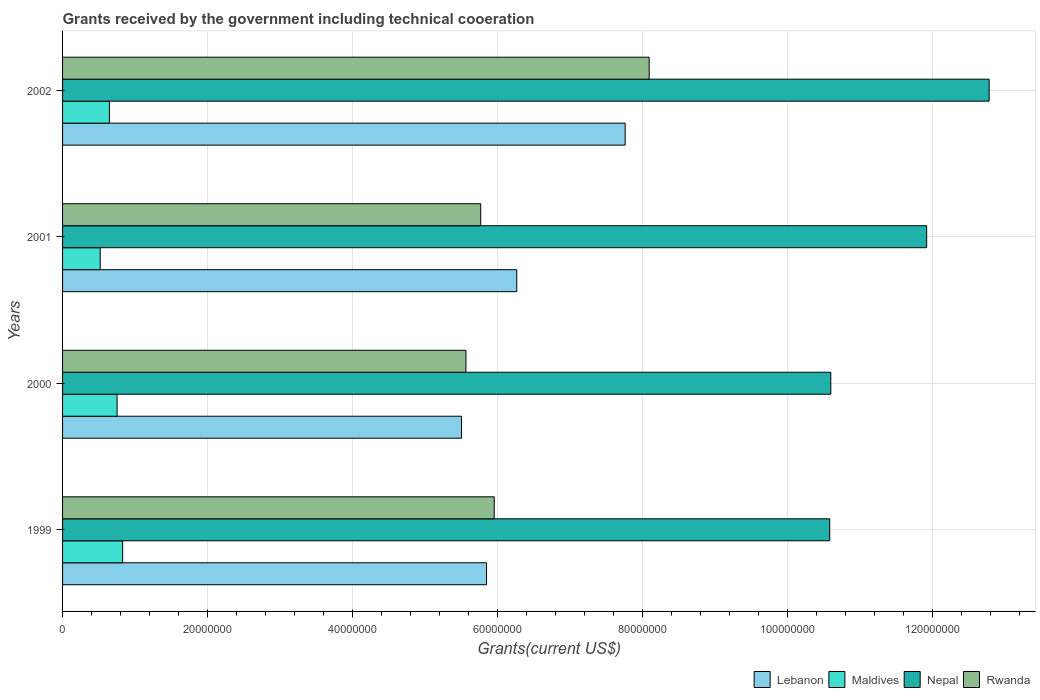How many groups of bars are there?
Keep it short and to the point. 4. In how many cases, is the number of bars for a given year not equal to the number of legend labels?
Give a very brief answer. 0. What is the total grants received by the government in Nepal in 2002?
Offer a very short reply. 1.28e+08. Across all years, what is the maximum total grants received by the government in Lebanon?
Ensure brevity in your answer.  7.76e+07. Across all years, what is the minimum total grants received by the government in Maldives?
Provide a short and direct response. 5.19e+06. What is the total total grants received by the government in Rwanda in the graph?
Offer a terse response. 2.54e+08. What is the difference between the total grants received by the government in Maldives in 1999 and that in 2001?
Your response must be concise. 3.10e+06. What is the difference between the total grants received by the government in Nepal in 2000 and the total grants received by the government in Maldives in 2002?
Ensure brevity in your answer.  9.95e+07. What is the average total grants received by the government in Lebanon per year?
Provide a short and direct response. 6.34e+07. In the year 1999, what is the difference between the total grants received by the government in Nepal and total grants received by the government in Rwanda?
Provide a succinct answer. 4.63e+07. In how many years, is the total grants received by the government in Lebanon greater than 68000000 US$?
Your response must be concise. 1. What is the ratio of the total grants received by the government in Maldives in 1999 to that in 2001?
Keep it short and to the point. 1.6. What is the difference between the highest and the second highest total grants received by the government in Rwanda?
Provide a succinct answer. 2.14e+07. What is the difference between the highest and the lowest total grants received by the government in Lebanon?
Your response must be concise. 2.26e+07. Is the sum of the total grants received by the government in Maldives in 2001 and 2002 greater than the maximum total grants received by the government in Rwanda across all years?
Offer a terse response. No. What does the 2nd bar from the top in 2002 represents?
Keep it short and to the point. Nepal. What does the 1st bar from the bottom in 2000 represents?
Make the answer very short. Lebanon. What is the difference between two consecutive major ticks on the X-axis?
Offer a very short reply. 2.00e+07. Are the values on the major ticks of X-axis written in scientific E-notation?
Offer a terse response. No. Does the graph contain grids?
Ensure brevity in your answer.  Yes. How many legend labels are there?
Offer a terse response. 4. What is the title of the graph?
Keep it short and to the point. Grants received by the government including technical cooeration. What is the label or title of the X-axis?
Your response must be concise. Grants(current US$). What is the label or title of the Y-axis?
Your answer should be very brief. Years. What is the Grants(current US$) in Lebanon in 1999?
Your response must be concise. 5.85e+07. What is the Grants(current US$) of Maldives in 1999?
Your response must be concise. 8.29e+06. What is the Grants(current US$) in Nepal in 1999?
Give a very brief answer. 1.06e+08. What is the Grants(current US$) of Rwanda in 1999?
Give a very brief answer. 5.95e+07. What is the Grants(current US$) of Lebanon in 2000?
Provide a short and direct response. 5.50e+07. What is the Grants(current US$) of Maldives in 2000?
Keep it short and to the point. 7.52e+06. What is the Grants(current US$) of Nepal in 2000?
Offer a terse response. 1.06e+08. What is the Grants(current US$) in Rwanda in 2000?
Your answer should be compact. 5.56e+07. What is the Grants(current US$) of Lebanon in 2001?
Provide a succinct answer. 6.26e+07. What is the Grants(current US$) in Maldives in 2001?
Your answer should be very brief. 5.19e+06. What is the Grants(current US$) of Nepal in 2001?
Provide a succinct answer. 1.19e+08. What is the Grants(current US$) in Rwanda in 2001?
Your answer should be compact. 5.77e+07. What is the Grants(current US$) of Lebanon in 2002?
Provide a succinct answer. 7.76e+07. What is the Grants(current US$) in Maldives in 2002?
Give a very brief answer. 6.46e+06. What is the Grants(current US$) in Nepal in 2002?
Your answer should be very brief. 1.28e+08. What is the Grants(current US$) of Rwanda in 2002?
Give a very brief answer. 8.09e+07. Across all years, what is the maximum Grants(current US$) of Lebanon?
Your answer should be compact. 7.76e+07. Across all years, what is the maximum Grants(current US$) in Maldives?
Provide a succinct answer. 8.29e+06. Across all years, what is the maximum Grants(current US$) in Nepal?
Offer a terse response. 1.28e+08. Across all years, what is the maximum Grants(current US$) of Rwanda?
Give a very brief answer. 8.09e+07. Across all years, what is the minimum Grants(current US$) in Lebanon?
Make the answer very short. 5.50e+07. Across all years, what is the minimum Grants(current US$) in Maldives?
Your response must be concise. 5.19e+06. Across all years, what is the minimum Grants(current US$) in Nepal?
Your response must be concise. 1.06e+08. Across all years, what is the minimum Grants(current US$) of Rwanda?
Your response must be concise. 5.56e+07. What is the total Grants(current US$) in Lebanon in the graph?
Provide a succinct answer. 2.54e+08. What is the total Grants(current US$) in Maldives in the graph?
Your response must be concise. 2.75e+07. What is the total Grants(current US$) of Nepal in the graph?
Make the answer very short. 4.59e+08. What is the total Grants(current US$) in Rwanda in the graph?
Keep it short and to the point. 2.54e+08. What is the difference between the Grants(current US$) of Lebanon in 1999 and that in 2000?
Ensure brevity in your answer.  3.45e+06. What is the difference between the Grants(current US$) in Maldives in 1999 and that in 2000?
Provide a succinct answer. 7.70e+05. What is the difference between the Grants(current US$) of Rwanda in 1999 and that in 2000?
Keep it short and to the point. 3.90e+06. What is the difference between the Grants(current US$) of Lebanon in 1999 and that in 2001?
Make the answer very short. -4.17e+06. What is the difference between the Grants(current US$) of Maldives in 1999 and that in 2001?
Provide a short and direct response. 3.10e+06. What is the difference between the Grants(current US$) in Nepal in 1999 and that in 2001?
Give a very brief answer. -1.34e+07. What is the difference between the Grants(current US$) in Rwanda in 1999 and that in 2001?
Ensure brevity in your answer.  1.86e+06. What is the difference between the Grants(current US$) in Lebanon in 1999 and that in 2002?
Provide a short and direct response. -1.91e+07. What is the difference between the Grants(current US$) in Maldives in 1999 and that in 2002?
Offer a very short reply. 1.83e+06. What is the difference between the Grants(current US$) of Nepal in 1999 and that in 2002?
Offer a very short reply. -2.20e+07. What is the difference between the Grants(current US$) of Rwanda in 1999 and that in 2002?
Keep it short and to the point. -2.14e+07. What is the difference between the Grants(current US$) of Lebanon in 2000 and that in 2001?
Ensure brevity in your answer.  -7.62e+06. What is the difference between the Grants(current US$) in Maldives in 2000 and that in 2001?
Your answer should be compact. 2.33e+06. What is the difference between the Grants(current US$) in Nepal in 2000 and that in 2001?
Your answer should be very brief. -1.32e+07. What is the difference between the Grants(current US$) of Rwanda in 2000 and that in 2001?
Your answer should be very brief. -2.04e+06. What is the difference between the Grants(current US$) of Lebanon in 2000 and that in 2002?
Your answer should be very brief. -2.26e+07. What is the difference between the Grants(current US$) in Maldives in 2000 and that in 2002?
Ensure brevity in your answer.  1.06e+06. What is the difference between the Grants(current US$) of Nepal in 2000 and that in 2002?
Make the answer very short. -2.18e+07. What is the difference between the Grants(current US$) of Rwanda in 2000 and that in 2002?
Your answer should be very brief. -2.53e+07. What is the difference between the Grants(current US$) in Lebanon in 2001 and that in 2002?
Provide a succinct answer. -1.50e+07. What is the difference between the Grants(current US$) in Maldives in 2001 and that in 2002?
Make the answer very short. -1.27e+06. What is the difference between the Grants(current US$) of Nepal in 2001 and that in 2002?
Your answer should be very brief. -8.62e+06. What is the difference between the Grants(current US$) in Rwanda in 2001 and that in 2002?
Provide a short and direct response. -2.32e+07. What is the difference between the Grants(current US$) of Lebanon in 1999 and the Grants(current US$) of Maldives in 2000?
Ensure brevity in your answer.  5.10e+07. What is the difference between the Grants(current US$) of Lebanon in 1999 and the Grants(current US$) of Nepal in 2000?
Give a very brief answer. -4.75e+07. What is the difference between the Grants(current US$) of Lebanon in 1999 and the Grants(current US$) of Rwanda in 2000?
Provide a succinct answer. 2.84e+06. What is the difference between the Grants(current US$) in Maldives in 1999 and the Grants(current US$) in Nepal in 2000?
Provide a short and direct response. -9.77e+07. What is the difference between the Grants(current US$) of Maldives in 1999 and the Grants(current US$) of Rwanda in 2000?
Your answer should be very brief. -4.73e+07. What is the difference between the Grants(current US$) in Nepal in 1999 and the Grants(current US$) in Rwanda in 2000?
Keep it short and to the point. 5.02e+07. What is the difference between the Grants(current US$) of Lebanon in 1999 and the Grants(current US$) of Maldives in 2001?
Your answer should be compact. 5.33e+07. What is the difference between the Grants(current US$) of Lebanon in 1999 and the Grants(current US$) of Nepal in 2001?
Provide a succinct answer. -6.07e+07. What is the difference between the Grants(current US$) in Maldives in 1999 and the Grants(current US$) in Nepal in 2001?
Provide a succinct answer. -1.11e+08. What is the difference between the Grants(current US$) in Maldives in 1999 and the Grants(current US$) in Rwanda in 2001?
Make the answer very short. -4.94e+07. What is the difference between the Grants(current US$) in Nepal in 1999 and the Grants(current US$) in Rwanda in 2001?
Your answer should be very brief. 4.81e+07. What is the difference between the Grants(current US$) of Lebanon in 1999 and the Grants(current US$) of Maldives in 2002?
Keep it short and to the point. 5.20e+07. What is the difference between the Grants(current US$) of Lebanon in 1999 and the Grants(current US$) of Nepal in 2002?
Your answer should be compact. -6.93e+07. What is the difference between the Grants(current US$) in Lebanon in 1999 and the Grants(current US$) in Rwanda in 2002?
Your response must be concise. -2.24e+07. What is the difference between the Grants(current US$) of Maldives in 1999 and the Grants(current US$) of Nepal in 2002?
Make the answer very short. -1.20e+08. What is the difference between the Grants(current US$) in Maldives in 1999 and the Grants(current US$) in Rwanda in 2002?
Make the answer very short. -7.26e+07. What is the difference between the Grants(current US$) in Nepal in 1999 and the Grants(current US$) in Rwanda in 2002?
Your response must be concise. 2.49e+07. What is the difference between the Grants(current US$) in Lebanon in 2000 and the Grants(current US$) in Maldives in 2001?
Provide a succinct answer. 4.98e+07. What is the difference between the Grants(current US$) of Lebanon in 2000 and the Grants(current US$) of Nepal in 2001?
Provide a short and direct response. -6.42e+07. What is the difference between the Grants(current US$) of Lebanon in 2000 and the Grants(current US$) of Rwanda in 2001?
Provide a succinct answer. -2.65e+06. What is the difference between the Grants(current US$) of Maldives in 2000 and the Grants(current US$) of Nepal in 2001?
Your answer should be compact. -1.12e+08. What is the difference between the Grants(current US$) of Maldives in 2000 and the Grants(current US$) of Rwanda in 2001?
Your answer should be compact. -5.02e+07. What is the difference between the Grants(current US$) in Nepal in 2000 and the Grants(current US$) in Rwanda in 2001?
Keep it short and to the point. 4.83e+07. What is the difference between the Grants(current US$) in Lebanon in 2000 and the Grants(current US$) in Maldives in 2002?
Your response must be concise. 4.86e+07. What is the difference between the Grants(current US$) in Lebanon in 2000 and the Grants(current US$) in Nepal in 2002?
Your answer should be very brief. -7.28e+07. What is the difference between the Grants(current US$) in Lebanon in 2000 and the Grants(current US$) in Rwanda in 2002?
Keep it short and to the point. -2.59e+07. What is the difference between the Grants(current US$) of Maldives in 2000 and the Grants(current US$) of Nepal in 2002?
Ensure brevity in your answer.  -1.20e+08. What is the difference between the Grants(current US$) of Maldives in 2000 and the Grants(current US$) of Rwanda in 2002?
Give a very brief answer. -7.34e+07. What is the difference between the Grants(current US$) in Nepal in 2000 and the Grants(current US$) in Rwanda in 2002?
Your response must be concise. 2.50e+07. What is the difference between the Grants(current US$) in Lebanon in 2001 and the Grants(current US$) in Maldives in 2002?
Your answer should be compact. 5.62e+07. What is the difference between the Grants(current US$) in Lebanon in 2001 and the Grants(current US$) in Nepal in 2002?
Your answer should be compact. -6.52e+07. What is the difference between the Grants(current US$) in Lebanon in 2001 and the Grants(current US$) in Rwanda in 2002?
Provide a succinct answer. -1.83e+07. What is the difference between the Grants(current US$) of Maldives in 2001 and the Grants(current US$) of Nepal in 2002?
Make the answer very short. -1.23e+08. What is the difference between the Grants(current US$) in Maldives in 2001 and the Grants(current US$) in Rwanda in 2002?
Offer a terse response. -7.57e+07. What is the difference between the Grants(current US$) in Nepal in 2001 and the Grants(current US$) in Rwanda in 2002?
Provide a succinct answer. 3.83e+07. What is the average Grants(current US$) in Lebanon per year?
Ensure brevity in your answer.  6.34e+07. What is the average Grants(current US$) in Maldives per year?
Your response must be concise. 6.86e+06. What is the average Grants(current US$) in Nepal per year?
Offer a very short reply. 1.15e+08. What is the average Grants(current US$) of Rwanda per year?
Your response must be concise. 6.34e+07. In the year 1999, what is the difference between the Grants(current US$) in Lebanon and Grants(current US$) in Maldives?
Keep it short and to the point. 5.02e+07. In the year 1999, what is the difference between the Grants(current US$) in Lebanon and Grants(current US$) in Nepal?
Offer a very short reply. -4.73e+07. In the year 1999, what is the difference between the Grants(current US$) in Lebanon and Grants(current US$) in Rwanda?
Provide a succinct answer. -1.06e+06. In the year 1999, what is the difference between the Grants(current US$) in Maldives and Grants(current US$) in Nepal?
Offer a terse response. -9.75e+07. In the year 1999, what is the difference between the Grants(current US$) of Maldives and Grants(current US$) of Rwanda?
Your answer should be compact. -5.12e+07. In the year 1999, what is the difference between the Grants(current US$) of Nepal and Grants(current US$) of Rwanda?
Give a very brief answer. 4.63e+07. In the year 2000, what is the difference between the Grants(current US$) in Lebanon and Grants(current US$) in Maldives?
Your answer should be very brief. 4.75e+07. In the year 2000, what is the difference between the Grants(current US$) in Lebanon and Grants(current US$) in Nepal?
Your response must be concise. -5.09e+07. In the year 2000, what is the difference between the Grants(current US$) in Lebanon and Grants(current US$) in Rwanda?
Keep it short and to the point. -6.10e+05. In the year 2000, what is the difference between the Grants(current US$) of Maldives and Grants(current US$) of Nepal?
Provide a short and direct response. -9.84e+07. In the year 2000, what is the difference between the Grants(current US$) of Maldives and Grants(current US$) of Rwanda?
Your answer should be compact. -4.81e+07. In the year 2000, what is the difference between the Grants(current US$) in Nepal and Grants(current US$) in Rwanda?
Offer a terse response. 5.03e+07. In the year 2001, what is the difference between the Grants(current US$) in Lebanon and Grants(current US$) in Maldives?
Offer a terse response. 5.74e+07. In the year 2001, what is the difference between the Grants(current US$) in Lebanon and Grants(current US$) in Nepal?
Make the answer very short. -5.65e+07. In the year 2001, what is the difference between the Grants(current US$) in Lebanon and Grants(current US$) in Rwanda?
Your answer should be very brief. 4.97e+06. In the year 2001, what is the difference between the Grants(current US$) of Maldives and Grants(current US$) of Nepal?
Your answer should be compact. -1.14e+08. In the year 2001, what is the difference between the Grants(current US$) of Maldives and Grants(current US$) of Rwanda?
Keep it short and to the point. -5.25e+07. In the year 2001, what is the difference between the Grants(current US$) of Nepal and Grants(current US$) of Rwanda?
Your answer should be compact. 6.15e+07. In the year 2002, what is the difference between the Grants(current US$) of Lebanon and Grants(current US$) of Maldives?
Your answer should be compact. 7.11e+07. In the year 2002, what is the difference between the Grants(current US$) in Lebanon and Grants(current US$) in Nepal?
Offer a terse response. -5.02e+07. In the year 2002, what is the difference between the Grants(current US$) of Lebanon and Grants(current US$) of Rwanda?
Provide a succinct answer. -3.31e+06. In the year 2002, what is the difference between the Grants(current US$) in Maldives and Grants(current US$) in Nepal?
Give a very brief answer. -1.21e+08. In the year 2002, what is the difference between the Grants(current US$) in Maldives and Grants(current US$) in Rwanda?
Provide a short and direct response. -7.44e+07. In the year 2002, what is the difference between the Grants(current US$) of Nepal and Grants(current US$) of Rwanda?
Offer a very short reply. 4.69e+07. What is the ratio of the Grants(current US$) of Lebanon in 1999 to that in 2000?
Keep it short and to the point. 1.06. What is the ratio of the Grants(current US$) of Maldives in 1999 to that in 2000?
Offer a terse response. 1.1. What is the ratio of the Grants(current US$) of Nepal in 1999 to that in 2000?
Give a very brief answer. 1. What is the ratio of the Grants(current US$) in Rwanda in 1999 to that in 2000?
Offer a very short reply. 1.07. What is the ratio of the Grants(current US$) in Lebanon in 1999 to that in 2001?
Provide a succinct answer. 0.93. What is the ratio of the Grants(current US$) in Maldives in 1999 to that in 2001?
Offer a very short reply. 1.6. What is the ratio of the Grants(current US$) of Nepal in 1999 to that in 2001?
Give a very brief answer. 0.89. What is the ratio of the Grants(current US$) of Rwanda in 1999 to that in 2001?
Your response must be concise. 1.03. What is the ratio of the Grants(current US$) in Lebanon in 1999 to that in 2002?
Provide a succinct answer. 0.75. What is the ratio of the Grants(current US$) in Maldives in 1999 to that in 2002?
Offer a very short reply. 1.28. What is the ratio of the Grants(current US$) in Nepal in 1999 to that in 2002?
Provide a succinct answer. 0.83. What is the ratio of the Grants(current US$) in Rwanda in 1999 to that in 2002?
Make the answer very short. 0.74. What is the ratio of the Grants(current US$) in Lebanon in 2000 to that in 2001?
Give a very brief answer. 0.88. What is the ratio of the Grants(current US$) in Maldives in 2000 to that in 2001?
Give a very brief answer. 1.45. What is the ratio of the Grants(current US$) in Nepal in 2000 to that in 2001?
Your answer should be very brief. 0.89. What is the ratio of the Grants(current US$) of Rwanda in 2000 to that in 2001?
Your answer should be very brief. 0.96. What is the ratio of the Grants(current US$) of Lebanon in 2000 to that in 2002?
Provide a succinct answer. 0.71. What is the ratio of the Grants(current US$) in Maldives in 2000 to that in 2002?
Offer a very short reply. 1.16. What is the ratio of the Grants(current US$) in Nepal in 2000 to that in 2002?
Keep it short and to the point. 0.83. What is the ratio of the Grants(current US$) of Rwanda in 2000 to that in 2002?
Ensure brevity in your answer.  0.69. What is the ratio of the Grants(current US$) of Lebanon in 2001 to that in 2002?
Your answer should be very brief. 0.81. What is the ratio of the Grants(current US$) in Maldives in 2001 to that in 2002?
Give a very brief answer. 0.8. What is the ratio of the Grants(current US$) in Nepal in 2001 to that in 2002?
Keep it short and to the point. 0.93. What is the ratio of the Grants(current US$) of Rwanda in 2001 to that in 2002?
Keep it short and to the point. 0.71. What is the difference between the highest and the second highest Grants(current US$) in Lebanon?
Offer a terse response. 1.50e+07. What is the difference between the highest and the second highest Grants(current US$) of Maldives?
Make the answer very short. 7.70e+05. What is the difference between the highest and the second highest Grants(current US$) of Nepal?
Your response must be concise. 8.62e+06. What is the difference between the highest and the second highest Grants(current US$) of Rwanda?
Offer a very short reply. 2.14e+07. What is the difference between the highest and the lowest Grants(current US$) of Lebanon?
Your answer should be very brief. 2.26e+07. What is the difference between the highest and the lowest Grants(current US$) of Maldives?
Your answer should be very brief. 3.10e+06. What is the difference between the highest and the lowest Grants(current US$) of Nepal?
Offer a terse response. 2.20e+07. What is the difference between the highest and the lowest Grants(current US$) in Rwanda?
Offer a very short reply. 2.53e+07. 